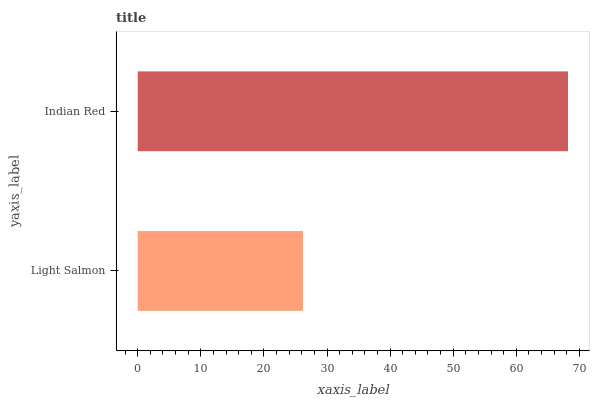Is Light Salmon the minimum?
Answer yes or no. Yes. Is Indian Red the maximum?
Answer yes or no. Yes. Is Indian Red the minimum?
Answer yes or no. No. Is Indian Red greater than Light Salmon?
Answer yes or no. Yes. Is Light Salmon less than Indian Red?
Answer yes or no. Yes. Is Light Salmon greater than Indian Red?
Answer yes or no. No. Is Indian Red less than Light Salmon?
Answer yes or no. No. Is Indian Red the high median?
Answer yes or no. Yes. Is Light Salmon the low median?
Answer yes or no. Yes. Is Light Salmon the high median?
Answer yes or no. No. Is Indian Red the low median?
Answer yes or no. No. 